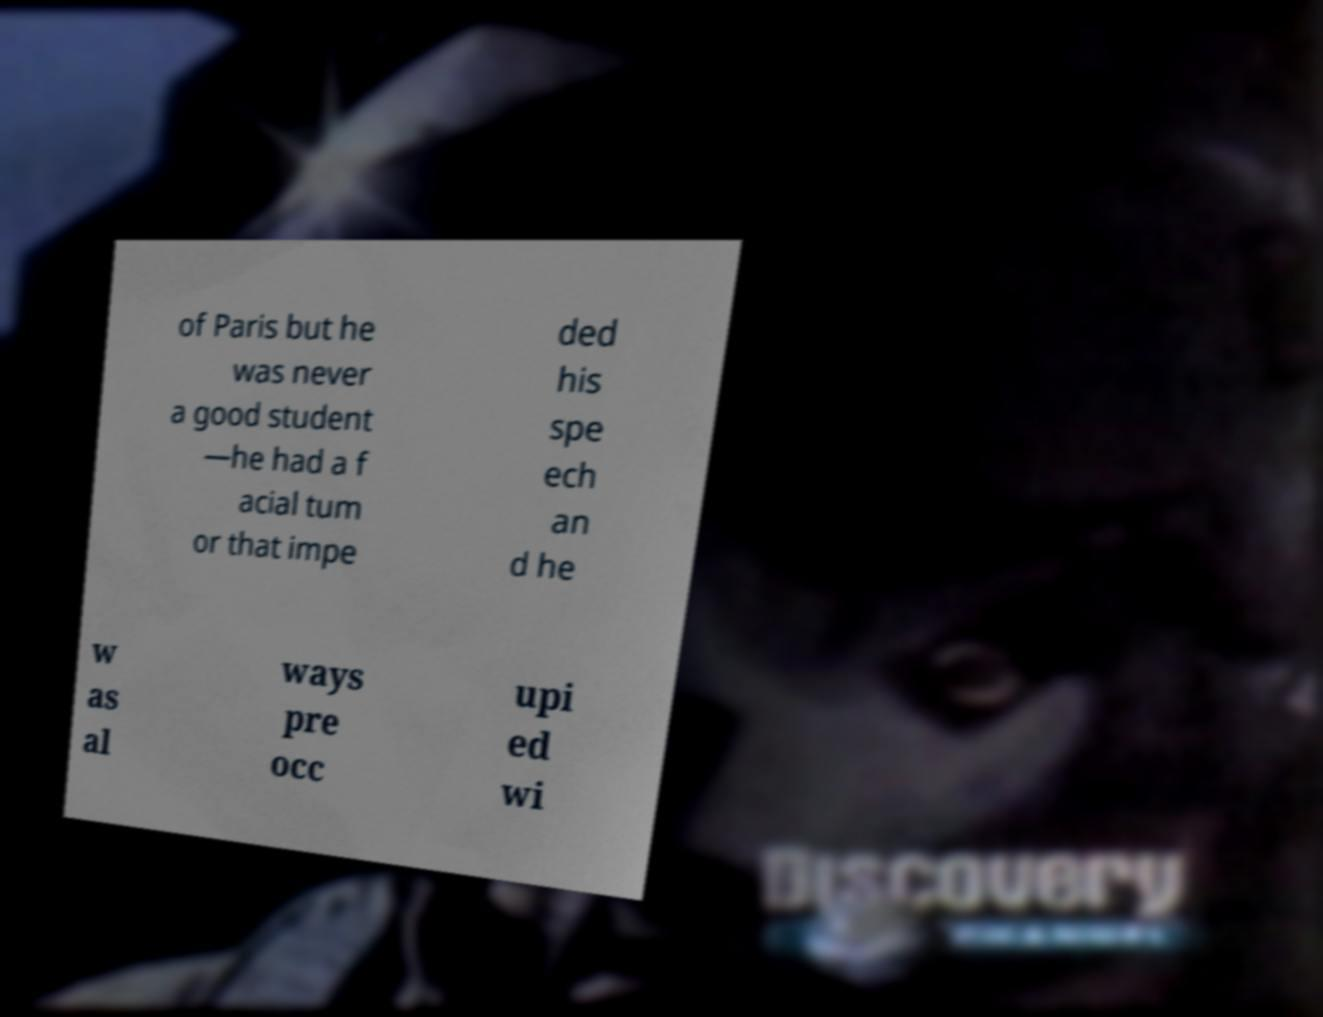Could you assist in decoding the text presented in this image and type it out clearly? of Paris but he was never a good student —he had a f acial tum or that impe ded his spe ech an d he w as al ways pre occ upi ed wi 